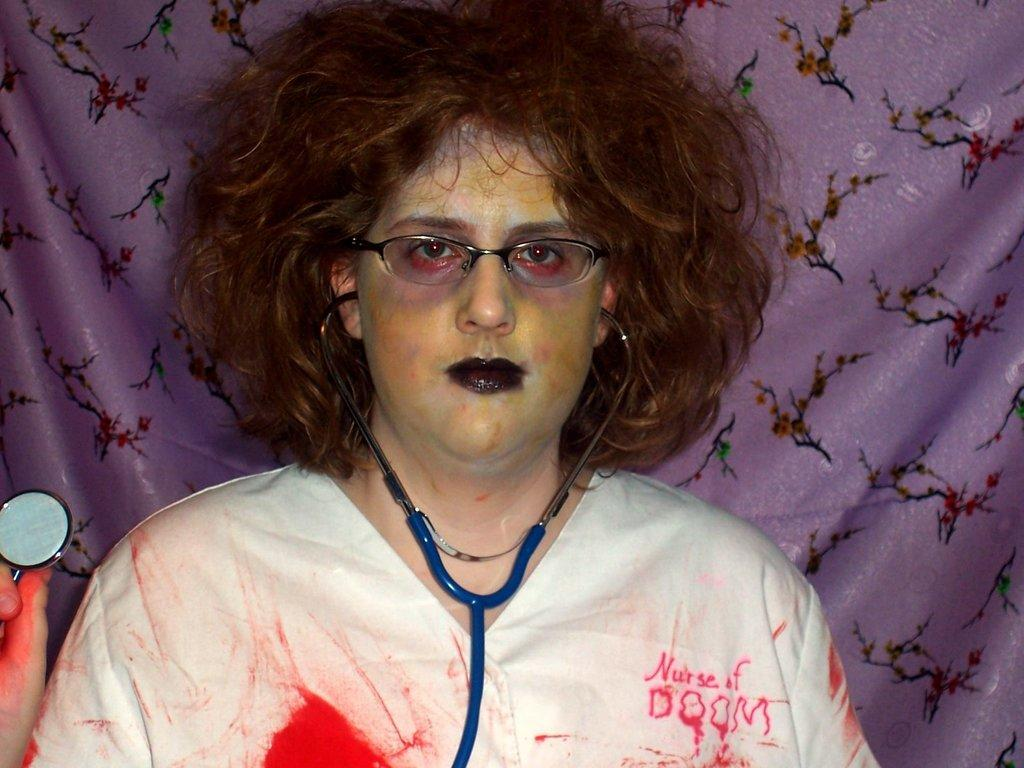Who is present in the image? There is a woman in the image. What is the woman wearing? The woman is wearing a white dress. What object is the woman holding? The woman is holding a stethoscope. What color is the curtain in the image? There is a purple curtain in the image. What type of pickle is the woman eating in the image? There is no pickle present in the image, and the woman is not eating anything. 